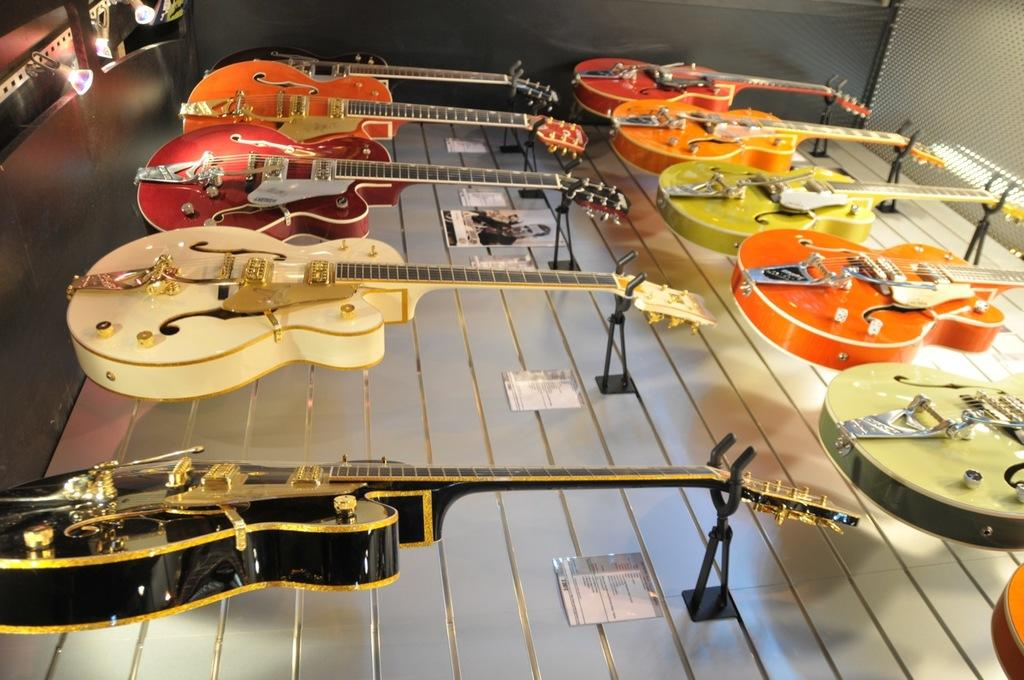What musical instruments are present in the image? There are guitars in the image. Where are the guitars located? The guitars are placed on a table. What type of rat can be seen playing the guitar in the image? There is no rat present in the image, and the guitars are not being played by any animals. 